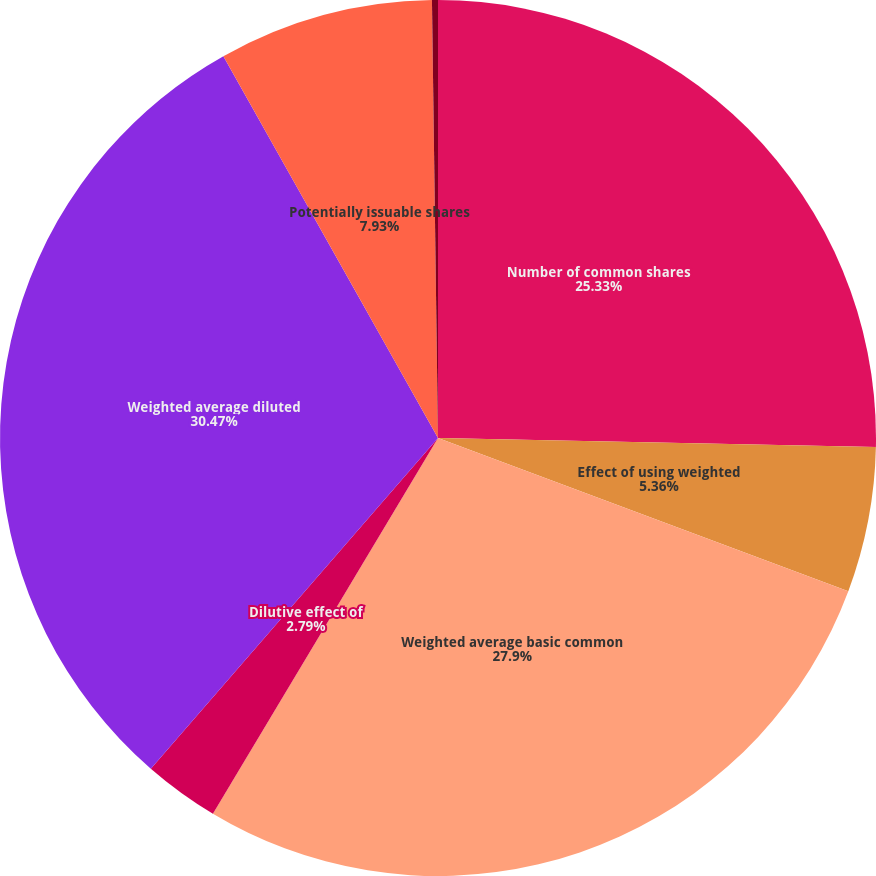Convert chart to OTSL. <chart><loc_0><loc_0><loc_500><loc_500><pie_chart><fcel>Number of common shares<fcel>Effect of using weighted<fcel>Weighted average basic common<fcel>Dilutive effect of<fcel>Weighted average diluted<fcel>Potentially issuable shares<fcel>Number of anti-dilutive<nl><fcel>25.33%<fcel>5.36%<fcel>27.9%<fcel>2.79%<fcel>30.47%<fcel>7.93%<fcel>0.22%<nl></chart> 